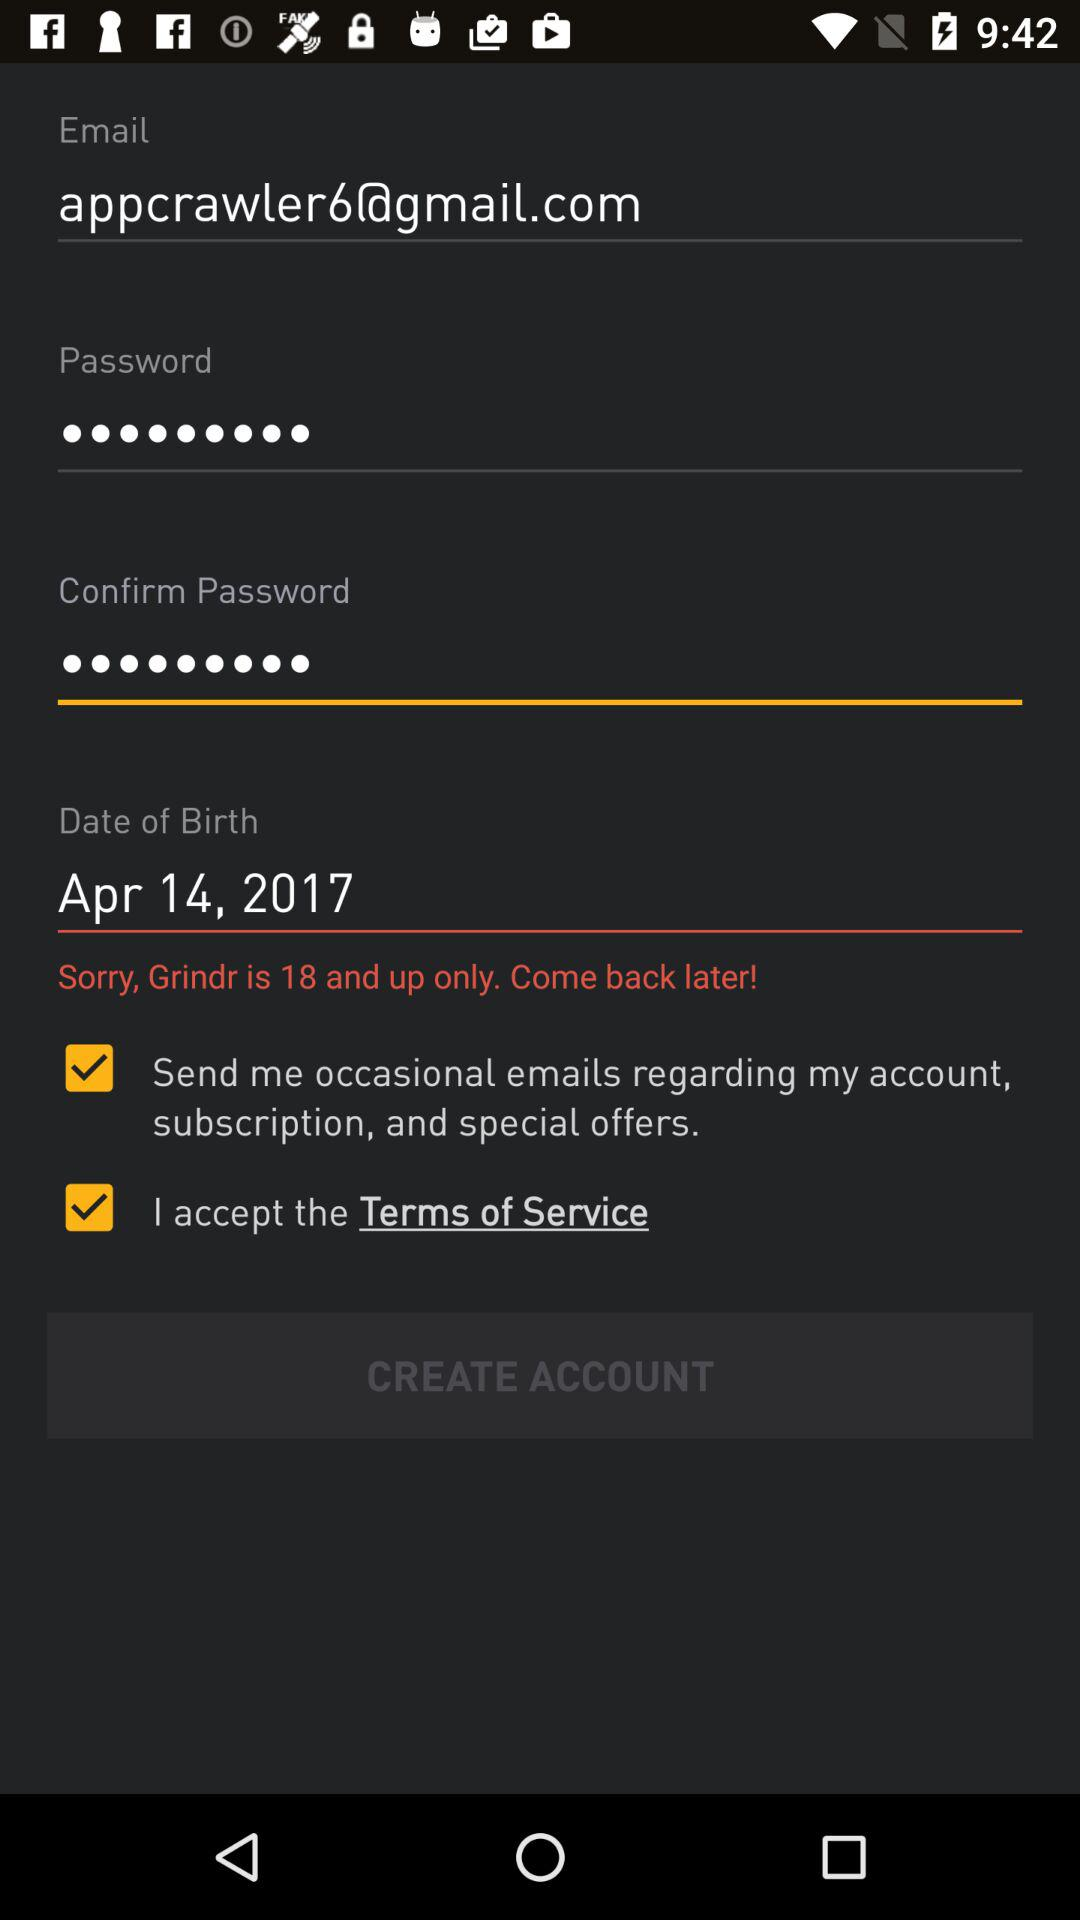What is the date of birth of the user? The birth date of the user is April 14, 2017. 